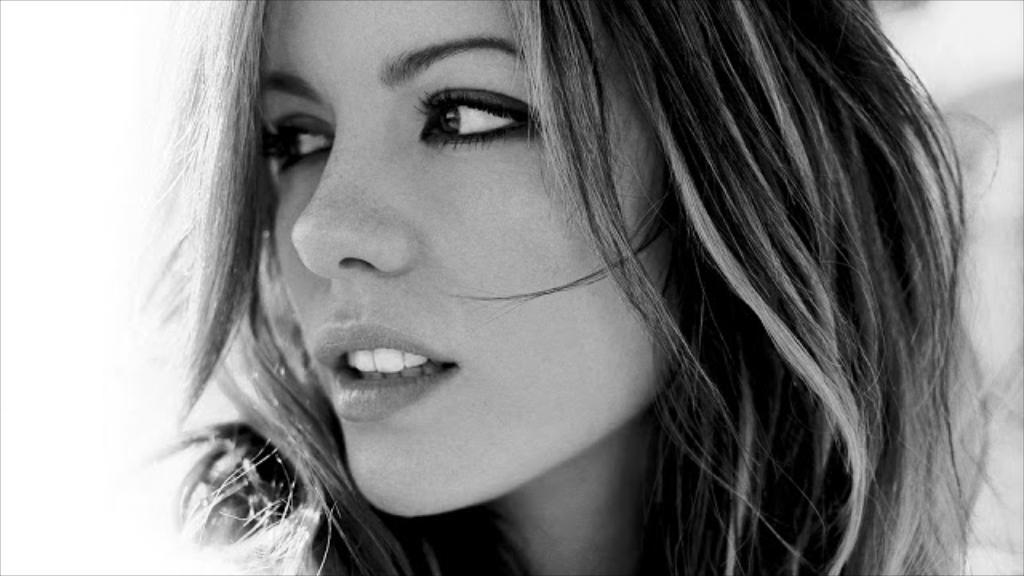Who is the main subject in the image? There is a woman in the image. Can you describe the background of the image? The background of the image is blurry. What type of turkey can be seen in the image? There is no turkey present in the image. Which direction is the sun facing in the image? The sun is not visible in the image, so it is not possible to determine its direction. 